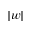Convert formula to latex. <formula><loc_0><loc_0><loc_500><loc_500>| w |</formula> 